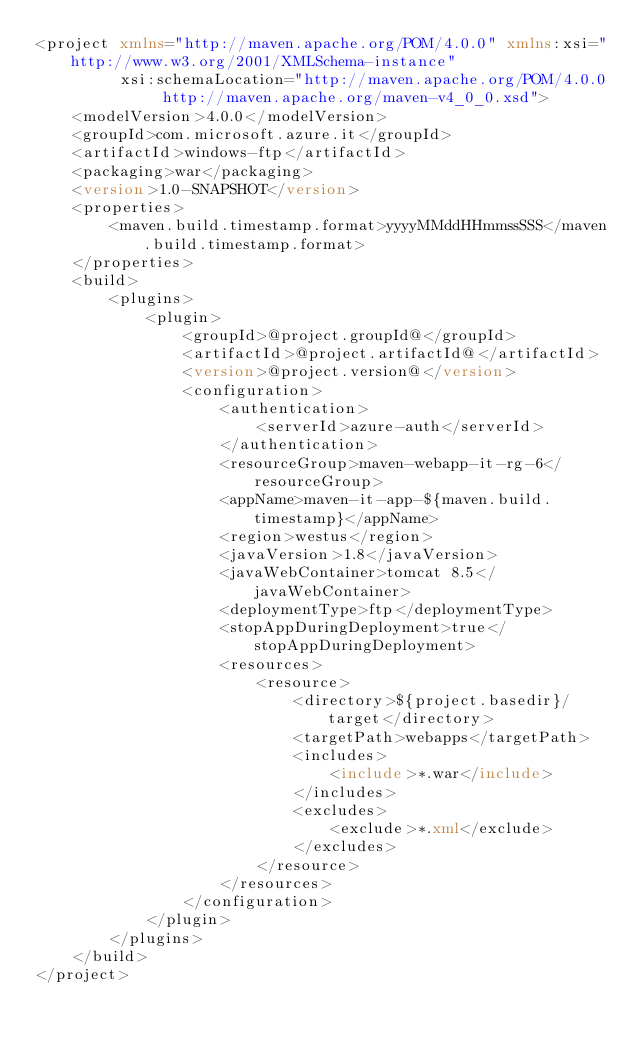<code> <loc_0><loc_0><loc_500><loc_500><_XML_><project xmlns="http://maven.apache.org/POM/4.0.0" xmlns:xsi="http://www.w3.org/2001/XMLSchema-instance"
         xsi:schemaLocation="http://maven.apache.org/POM/4.0.0 http://maven.apache.org/maven-v4_0_0.xsd">
    <modelVersion>4.0.0</modelVersion>
    <groupId>com.microsoft.azure.it</groupId>
    <artifactId>windows-ftp</artifactId>
    <packaging>war</packaging>
    <version>1.0-SNAPSHOT</version>
    <properties>
        <maven.build.timestamp.format>yyyyMMddHHmmssSSS</maven.build.timestamp.format>
    </properties>
    <build>
        <plugins>
            <plugin>
                <groupId>@project.groupId@</groupId>
                <artifactId>@project.artifactId@</artifactId>
                <version>@project.version@</version>
                <configuration>
                    <authentication>
                        <serverId>azure-auth</serverId>
                    </authentication>
                    <resourceGroup>maven-webapp-it-rg-6</resourceGroup>
                    <appName>maven-it-app-${maven.build.timestamp}</appName>
                    <region>westus</region>
                    <javaVersion>1.8</javaVersion>
                    <javaWebContainer>tomcat 8.5</javaWebContainer>
                    <deploymentType>ftp</deploymentType>
                    <stopAppDuringDeployment>true</stopAppDuringDeployment>
                    <resources>
                        <resource>
                            <directory>${project.basedir}/target</directory>
                            <targetPath>webapps</targetPath>
                            <includes>
                                <include>*.war</include>
                            </includes>
                            <excludes>
                                <exclude>*.xml</exclude>
                            </excludes>
                        </resource>
                    </resources>
                </configuration>
            </plugin>
        </plugins>
    </build>
</project>
</code> 